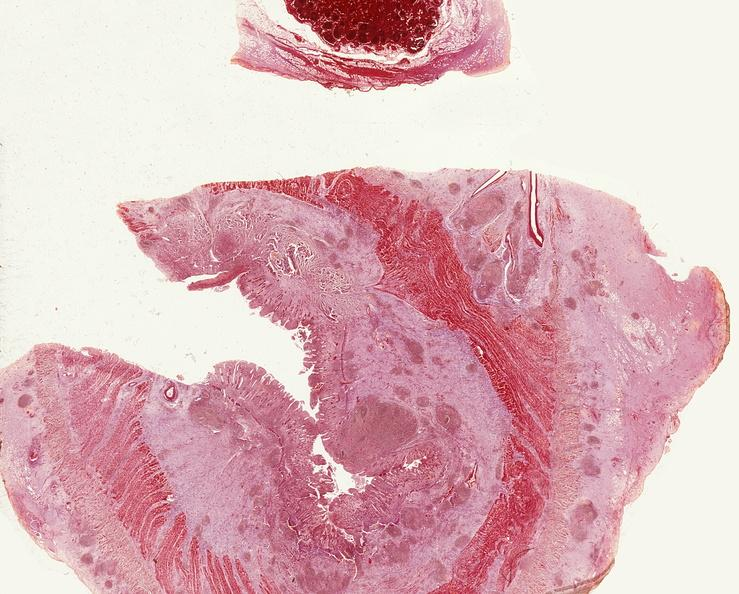s this section showing liver with tumor mass in hilar area tumor present?
Answer the question using a single word or phrase. No 